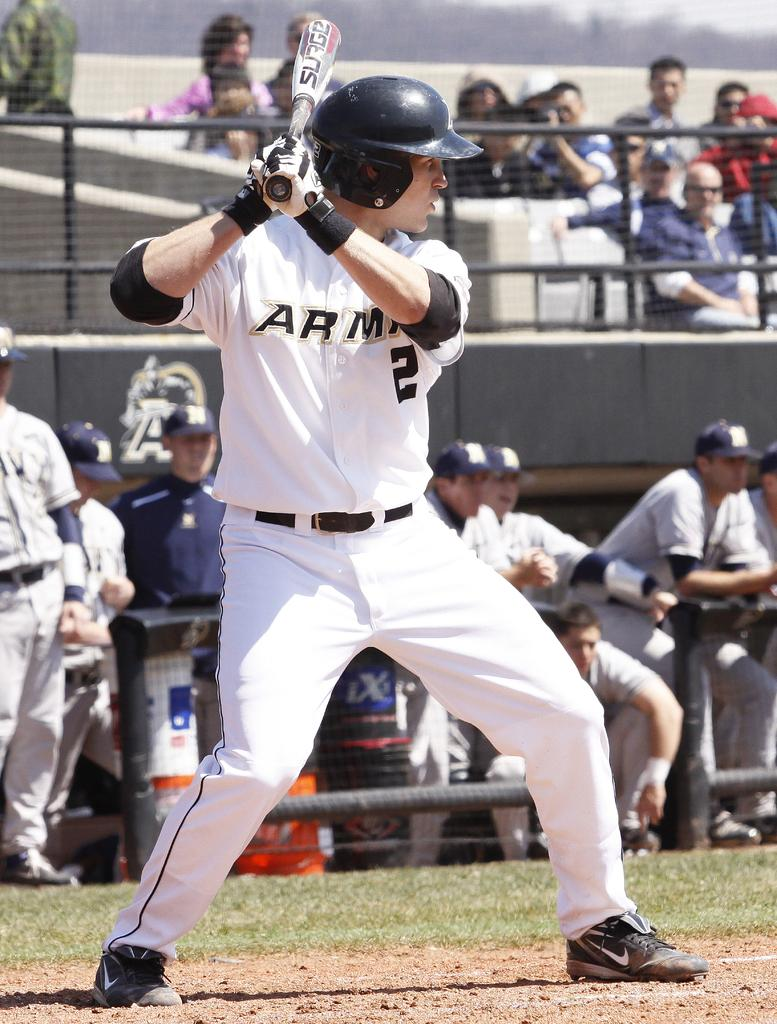<image>
Give a short and clear explanation of the subsequent image. a baseball player with the number 2 on 